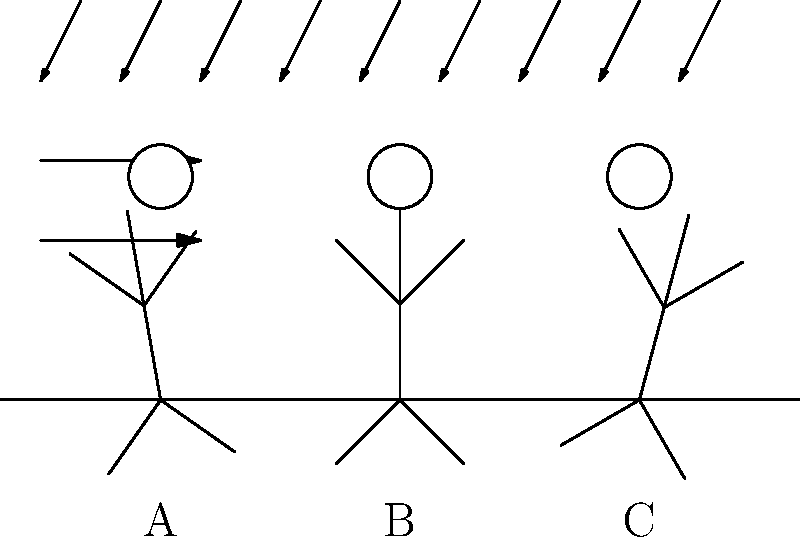In the diagram above, three stick figures (A, B, and C) represent individuals walking in rainy and windy conditions. Based on your knowledge of weather impacts on human gait, which figure is most likely to represent a person walking against the wind and rain? To answer this question, we need to consider how wind and rain affect a person's gait:

1. Wind resistance: When walking against the wind, people tend to lean forward to maintain balance and reduce air resistance.

2. Rain protection: In rainy conditions, people often tilt their heads downward to shield their faces from raindrops.

3. Stride length: Walking against wind and rain usually results in shorter, more frequent steps to maintain stability.

4. Arm position: People may hold their arms closer to their body or use them to shield their face from rain.

Analyzing the figures:

A: Leaning forward slightly, which suggests walking against the wind.
B: Standing upright, indicating no significant wind resistance.
C: Leaning backward, which is unlikely in windy conditions.

Considering the wind direction shown by the arrows in the upper left of the diagram, figure A is most consistent with walking against the wind and rain. The forward lean helps to counteract the wind resistance and provides some protection from the falling rain.
Answer: Figure A 